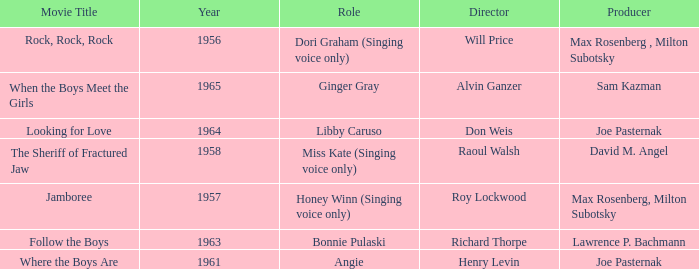What were the roles in 1961? Angie. 